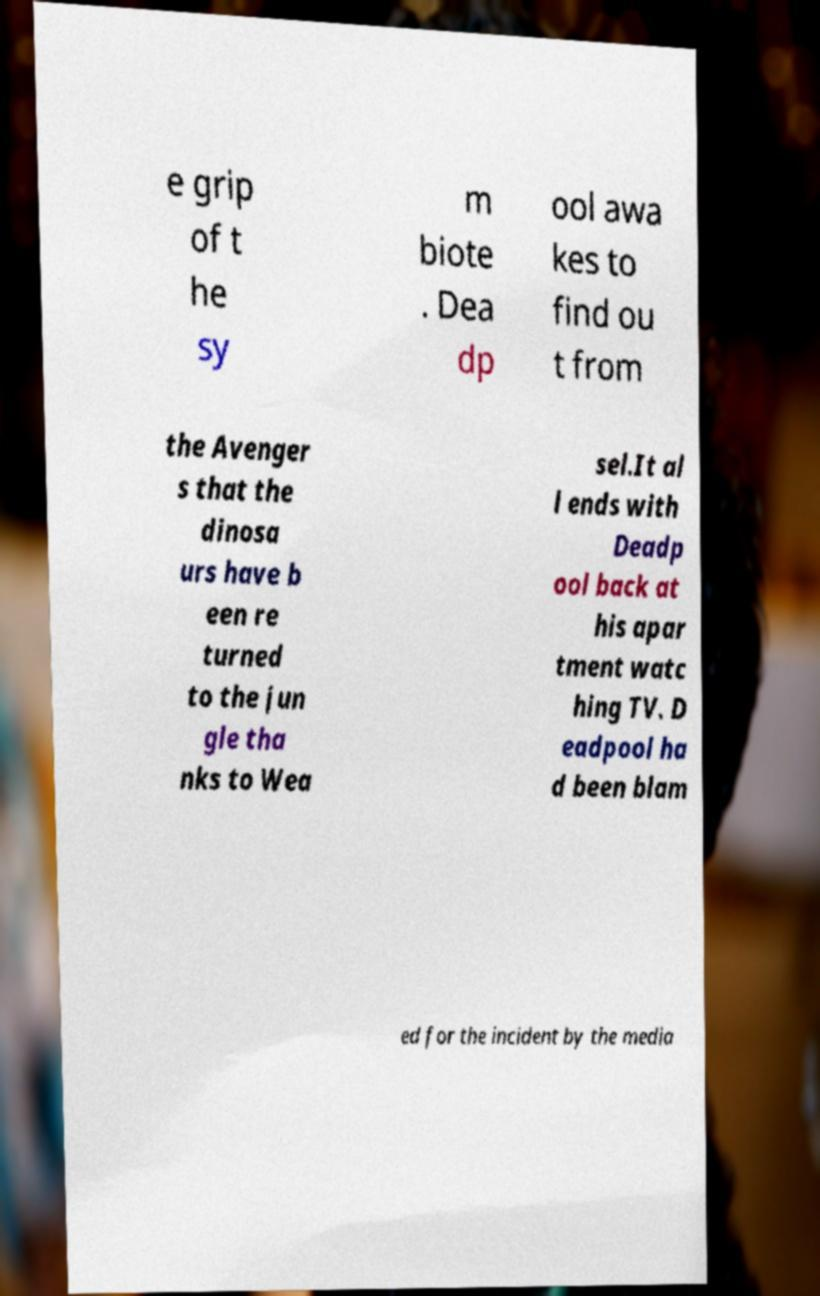What messages or text are displayed in this image? I need them in a readable, typed format. e grip of t he sy m biote . Dea dp ool awa kes to find ou t from the Avenger s that the dinosa urs have b een re turned to the jun gle tha nks to Wea sel.It al l ends with Deadp ool back at his apar tment watc hing TV. D eadpool ha d been blam ed for the incident by the media 